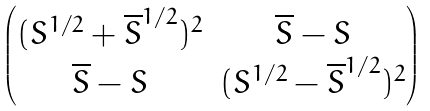<formula> <loc_0><loc_0><loc_500><loc_500>\begin{pmatrix} ( S ^ { 1 / 2 } + { \overline { S } } ^ { 1 / 2 } ) ^ { 2 } & \overline { S } - S \\ \overline { S } - S & ( S ^ { 1 / 2 } - { \overline { S } } ^ { 1 / 2 } ) ^ { 2 } \end{pmatrix}</formula> 